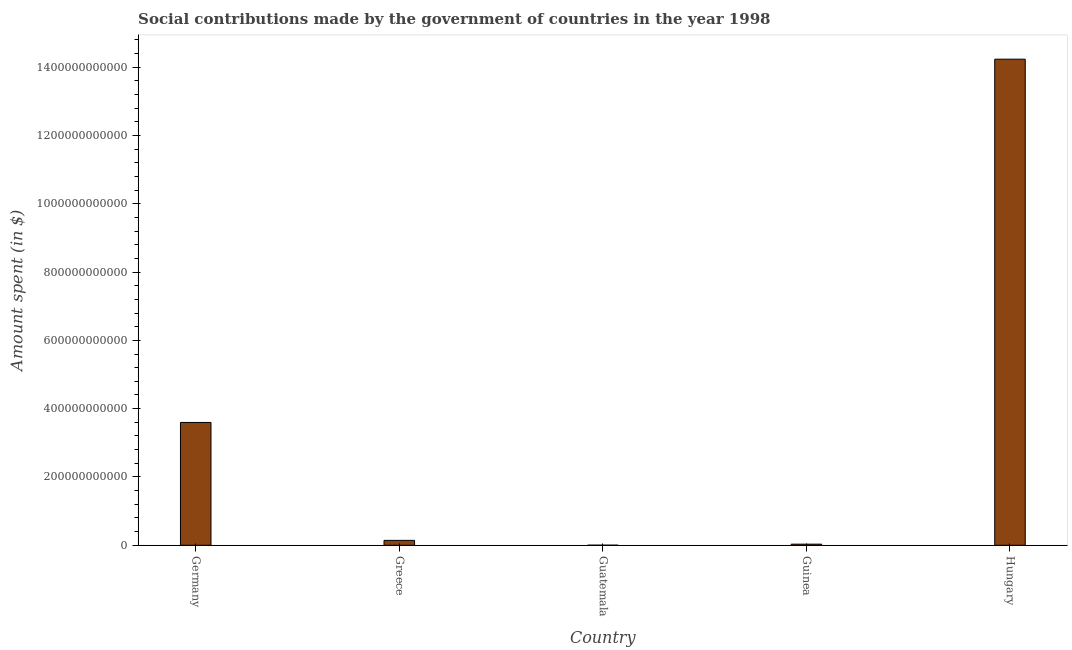Does the graph contain any zero values?
Your answer should be very brief. No. Does the graph contain grids?
Give a very brief answer. No. What is the title of the graph?
Provide a succinct answer. Social contributions made by the government of countries in the year 1998. What is the label or title of the X-axis?
Provide a succinct answer. Country. What is the label or title of the Y-axis?
Your response must be concise. Amount spent (in $). What is the amount spent in making social contributions in Germany?
Offer a terse response. 3.60e+11. Across all countries, what is the maximum amount spent in making social contributions?
Make the answer very short. 1.42e+12. Across all countries, what is the minimum amount spent in making social contributions?
Your response must be concise. 2.13e+08. In which country was the amount spent in making social contributions maximum?
Offer a terse response. Hungary. In which country was the amount spent in making social contributions minimum?
Give a very brief answer. Guatemala. What is the sum of the amount spent in making social contributions?
Keep it short and to the point. 1.80e+12. What is the difference between the amount spent in making social contributions in Greece and Hungary?
Your response must be concise. -1.41e+12. What is the average amount spent in making social contributions per country?
Offer a terse response. 3.60e+11. What is the median amount spent in making social contributions?
Your answer should be compact. 1.43e+1. What is the ratio of the amount spent in making social contributions in Greece to that in Guinea?
Offer a very short reply. 4.39. Is the difference between the amount spent in making social contributions in Guatemala and Hungary greater than the difference between any two countries?
Give a very brief answer. Yes. What is the difference between the highest and the second highest amount spent in making social contributions?
Keep it short and to the point. 1.06e+12. Is the sum of the amount spent in making social contributions in Guinea and Hungary greater than the maximum amount spent in making social contributions across all countries?
Offer a very short reply. Yes. What is the difference between the highest and the lowest amount spent in making social contributions?
Your response must be concise. 1.42e+12. What is the difference between two consecutive major ticks on the Y-axis?
Your answer should be compact. 2.00e+11. Are the values on the major ticks of Y-axis written in scientific E-notation?
Give a very brief answer. No. What is the Amount spent (in $) of Germany?
Provide a succinct answer. 3.60e+11. What is the Amount spent (in $) in Greece?
Your answer should be very brief. 1.43e+1. What is the Amount spent (in $) in Guatemala?
Your response must be concise. 2.13e+08. What is the Amount spent (in $) in Guinea?
Your answer should be very brief. 3.27e+09. What is the Amount spent (in $) of Hungary?
Keep it short and to the point. 1.42e+12. What is the difference between the Amount spent (in $) in Germany and Greece?
Provide a short and direct response. 3.45e+11. What is the difference between the Amount spent (in $) in Germany and Guatemala?
Your answer should be compact. 3.59e+11. What is the difference between the Amount spent (in $) in Germany and Guinea?
Offer a terse response. 3.56e+11. What is the difference between the Amount spent (in $) in Germany and Hungary?
Ensure brevity in your answer.  -1.06e+12. What is the difference between the Amount spent (in $) in Greece and Guatemala?
Your response must be concise. 1.41e+1. What is the difference between the Amount spent (in $) in Greece and Guinea?
Provide a short and direct response. 1.11e+1. What is the difference between the Amount spent (in $) in Greece and Hungary?
Provide a short and direct response. -1.41e+12. What is the difference between the Amount spent (in $) in Guatemala and Guinea?
Your answer should be very brief. -3.06e+09. What is the difference between the Amount spent (in $) in Guatemala and Hungary?
Provide a short and direct response. -1.42e+12. What is the difference between the Amount spent (in $) in Guinea and Hungary?
Ensure brevity in your answer.  -1.42e+12. What is the ratio of the Amount spent (in $) in Germany to that in Greece?
Offer a terse response. 25.07. What is the ratio of the Amount spent (in $) in Germany to that in Guatemala?
Keep it short and to the point. 1686.35. What is the ratio of the Amount spent (in $) in Germany to that in Guinea?
Provide a short and direct response. 109.96. What is the ratio of the Amount spent (in $) in Germany to that in Hungary?
Ensure brevity in your answer.  0.25. What is the ratio of the Amount spent (in $) in Greece to that in Guatemala?
Provide a succinct answer. 67.28. What is the ratio of the Amount spent (in $) in Greece to that in Guinea?
Make the answer very short. 4.39. What is the ratio of the Amount spent (in $) in Guatemala to that in Guinea?
Your answer should be compact. 0.07. What is the ratio of the Amount spent (in $) in Guinea to that in Hungary?
Provide a succinct answer. 0. 